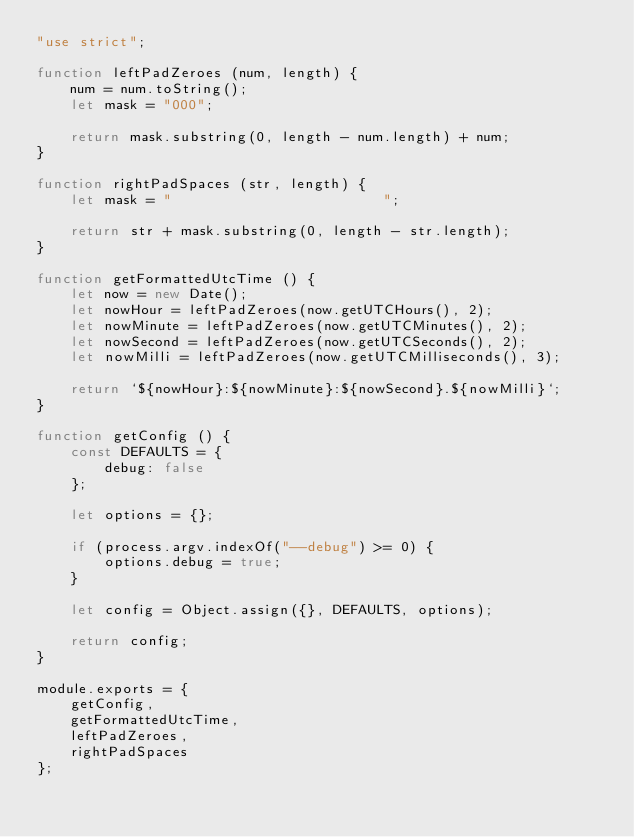Convert code to text. <code><loc_0><loc_0><loc_500><loc_500><_JavaScript_>"use strict";

function leftPadZeroes (num, length) {
	num = num.toString();
	let mask = "000";

	return mask.substring(0, length - num.length) + num;
}

function rightPadSpaces (str, length) {
	let mask = "                         ";

	return str + mask.substring(0, length - str.length);
}

function getFormattedUtcTime () {
	let now = new Date();
	let nowHour = leftPadZeroes(now.getUTCHours(), 2);
	let nowMinute = leftPadZeroes(now.getUTCMinutes(), 2);
	let nowSecond = leftPadZeroes(now.getUTCSeconds(), 2);
	let nowMilli = leftPadZeroes(now.getUTCMilliseconds(), 3);

	return `${nowHour}:${nowMinute}:${nowSecond}.${nowMilli}`;
}

function getConfig () {
	const DEFAULTS = {
		debug: false
	};

	let options = {};

	if (process.argv.indexOf("--debug") >= 0) {
		options.debug = true;
	}

	let config = Object.assign({}, DEFAULTS, options);

	return config;
}

module.exports = {
	getConfig,
	getFormattedUtcTime,
	leftPadZeroes,
	rightPadSpaces
};</code> 